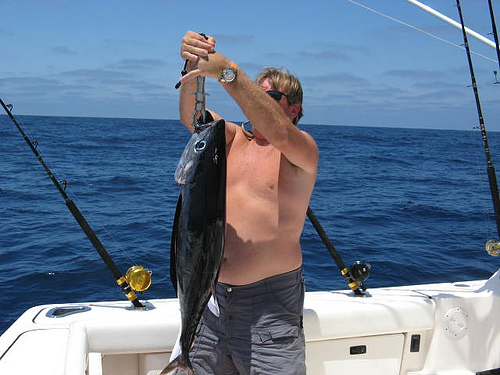<image>
Can you confirm if the fishing pole is behind the fish? Yes. From this viewpoint, the fishing pole is positioned behind the fish, with the fish partially or fully occluding the fishing pole. 